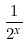Convert formula to latex. <formula><loc_0><loc_0><loc_500><loc_500>\frac { 1 } { 2 ^ { x } }</formula> 